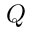<formula> <loc_0><loc_0><loc_500><loc_500>Q</formula> 